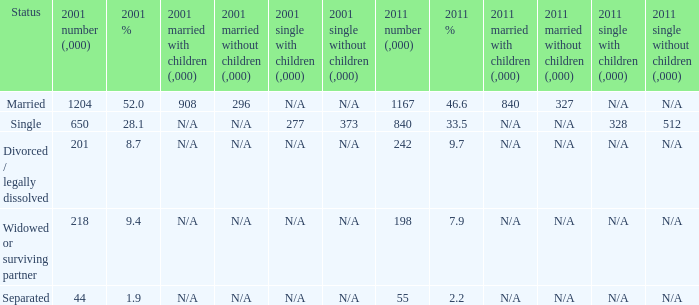What si the 2011 number (,000) when 2001 % is 28.1? 840.0. 